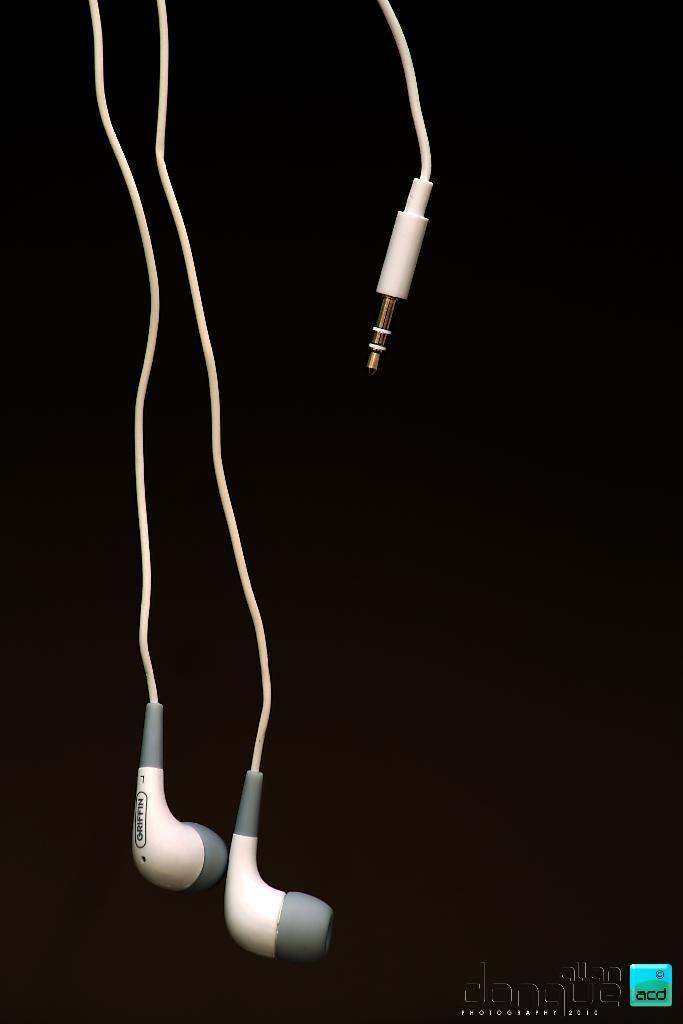Please provide a concise description of this image. In this image we can see headphones. In the bottom of the image we can see some text. 